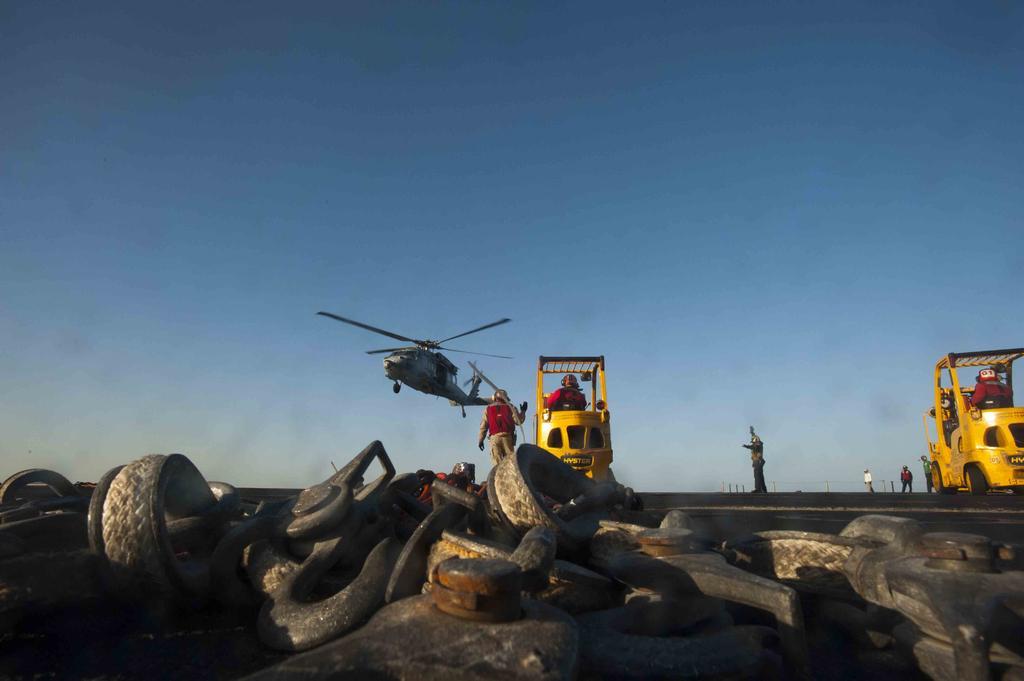Describe this image in one or two sentences. In the center of the image we can see persons and vehicles. At the bottom of the image we can see tires and machinery. In the background we can see helicopter and sky. 